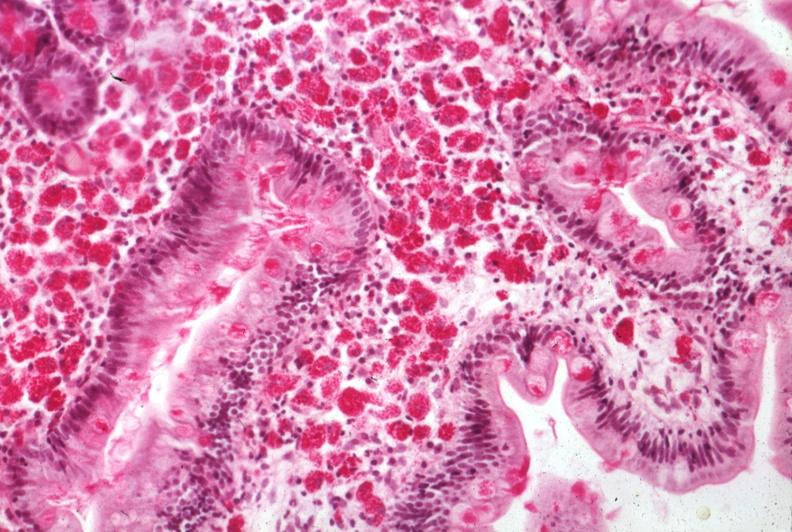s hemorrhage associated with placental abruption present?
Answer the question using a single word or phrase. No 